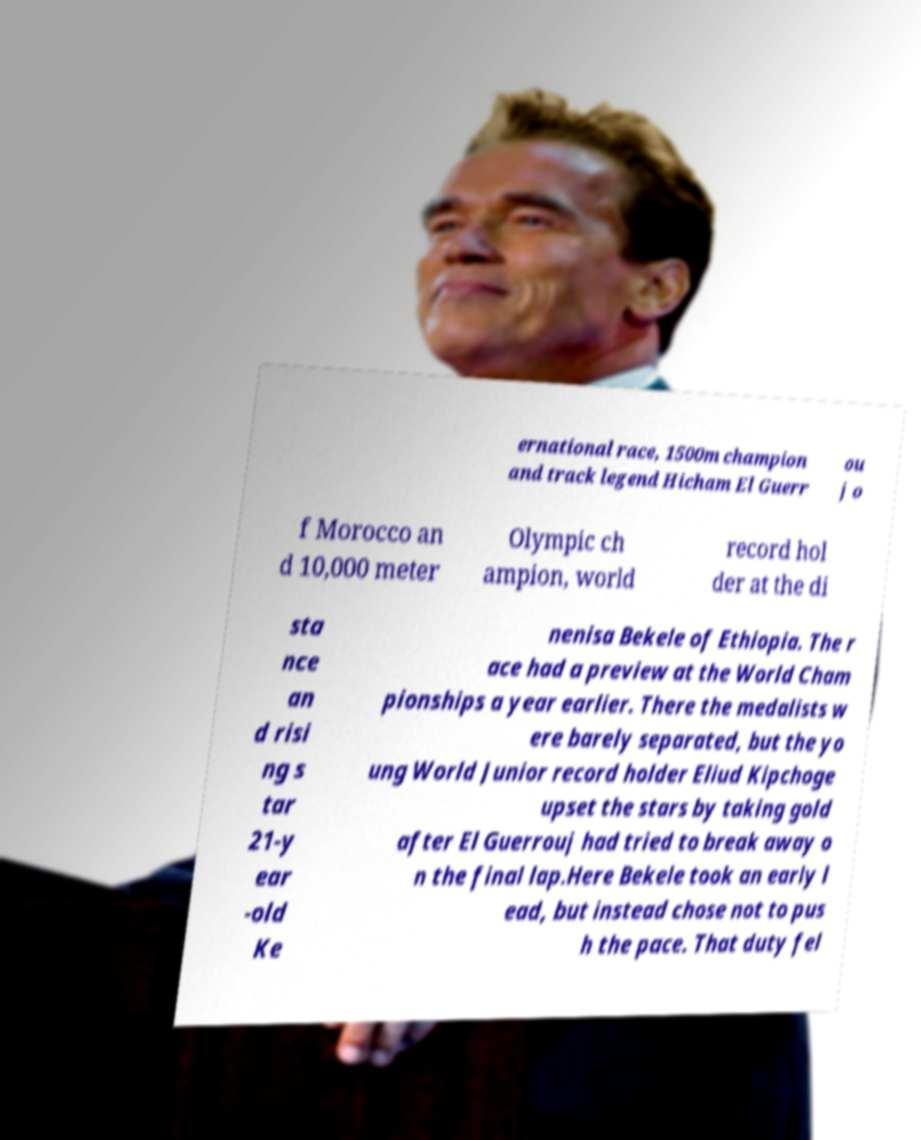Could you extract and type out the text from this image? ernational race, 1500m champion and track legend Hicham El Guerr ou j o f Morocco an d 10,000 meter Olympic ch ampion, world record hol der at the di sta nce an d risi ng s tar 21-y ear -old Ke nenisa Bekele of Ethiopia. The r ace had a preview at the World Cham pionships a year earlier. There the medalists w ere barely separated, but the yo ung World Junior record holder Eliud Kipchoge upset the stars by taking gold after El Guerrouj had tried to break away o n the final lap.Here Bekele took an early l ead, but instead chose not to pus h the pace. That duty fel 